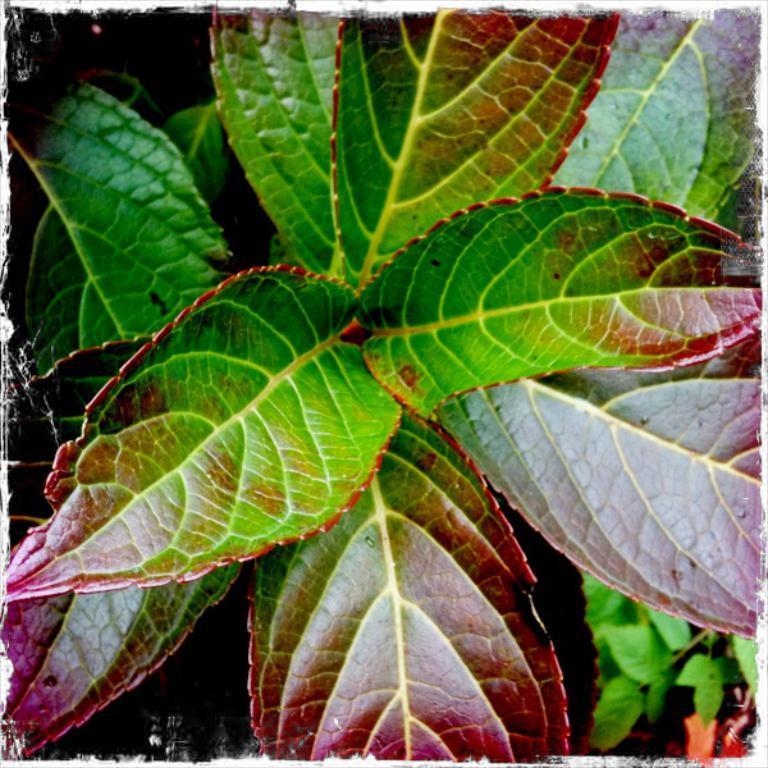In one or two sentences, can you explain what this image depicts? In this picture, there is a plant with leaves. 